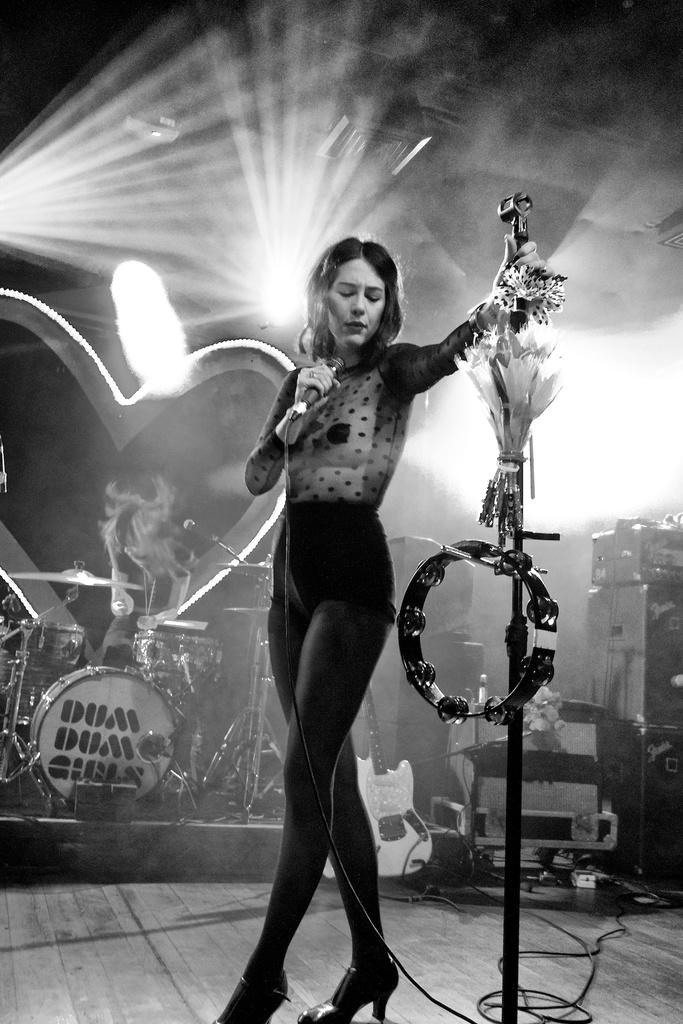Who is the main subject in the image? There is a woman in the image. What is the woman wearing? The woman is wearing a black dress. What is the woman holding in the image? The woman is holding a mic. What can be seen in the background of the image? There are lights, musical drums, and a building in the image. Can you see any grapes in the image? There are no grapes present in the image. What type of elbow is visible in the image? There is no elbow visible in the image. 